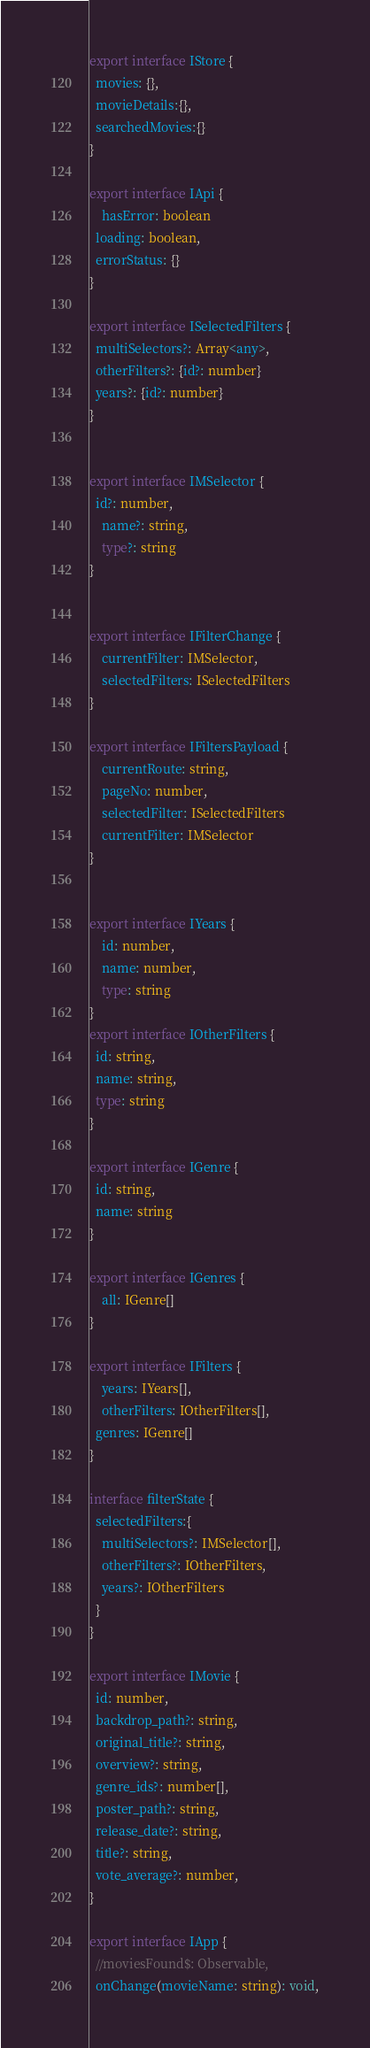<code> <loc_0><loc_0><loc_500><loc_500><_TypeScript_>export interface IStore {
  movies: {},
  movieDetails:{},
  searchedMovies:{}
}

export interface IApi {
	hasError: boolean
  loading: boolean,
  errorStatus: {}
}

export interface ISelectedFilters {
  multiSelectors?: Array<any>,
  otherFilters?: {id?: number}
  years?: {id?: number}
}


export interface IMSelector {
  id?: number,
	name?: string,
	type?: string
}


export interface IFilterChange {
	currentFilter: IMSelector,
	selectedFilters: ISelectedFilters
}

export interface IFiltersPayload {
	currentRoute: string,
	pageNo: number,
	selectedFilter: ISelectedFilters
	currentFilter: IMSelector
}


export interface IYears {
	id: number,
	name: number,
	type: string
}
export interface IOtherFilters {
  id: string,
  name: string,
  type: string
}

export interface IGenre {
  id: string,
  name: string
}

export interface IGenres {
	all: IGenre[]
}

export interface IFilters {
	years: IYears[],
	otherFilters: IOtherFilters[],
  genres: IGenre[]
}

interface filterState {
  selectedFilters:{
    multiSelectors?: IMSelector[],
    otherFilters?: IOtherFilters,
    years?: IOtherFilters
  }
}

export interface IMovie {
  id: number,
  backdrop_path?: string,
  original_title?: string,
  overview?: string,
  genre_ids?: number[],
  poster_path?: string,
  release_date?: string,
  title?: string,
  vote_average?: number,
}

export interface IApp {
  //moviesFound$: Observable,
  onChange(movieName: string): void,</code> 